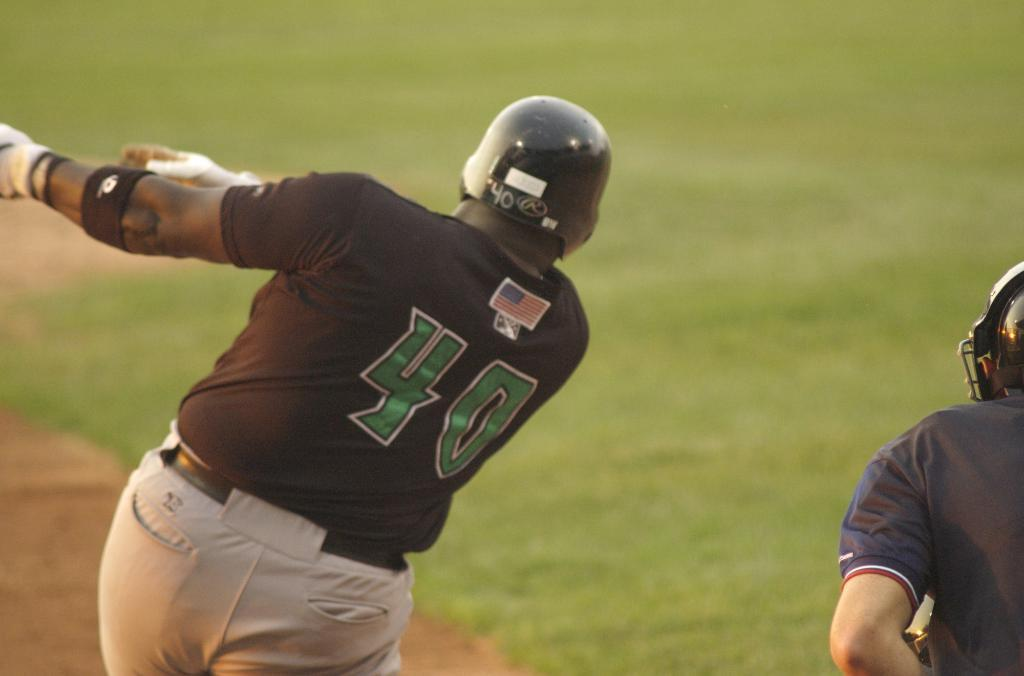What are the people in the image wearing on their heads? There is a person wearing gloves and a helmet, and another person wearing a helmet in the image. What can be seen on the ground in the image? There is grass visible in the image. What type of brake is the mom using in the office in the image? There is no mention of a mom, brake, or office in the image. The image features two people wearing helmets and grass visible on the ground. 